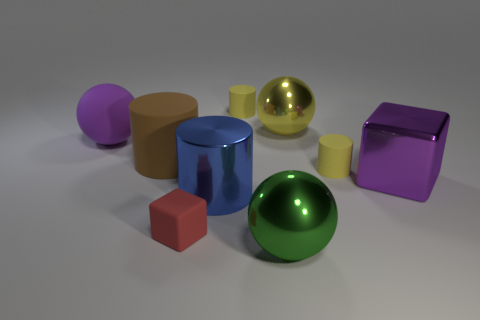Subtract all red blocks. Subtract all green spheres. How many blocks are left? 1 Add 1 purple things. How many objects exist? 10 Subtract all blocks. How many objects are left? 7 Add 7 purple matte blocks. How many purple matte blocks exist? 7 Subtract 0 green cylinders. How many objects are left? 9 Subtract all tiny yellow metal cubes. Subtract all purple objects. How many objects are left? 7 Add 5 green metal spheres. How many green metal spheres are left? 6 